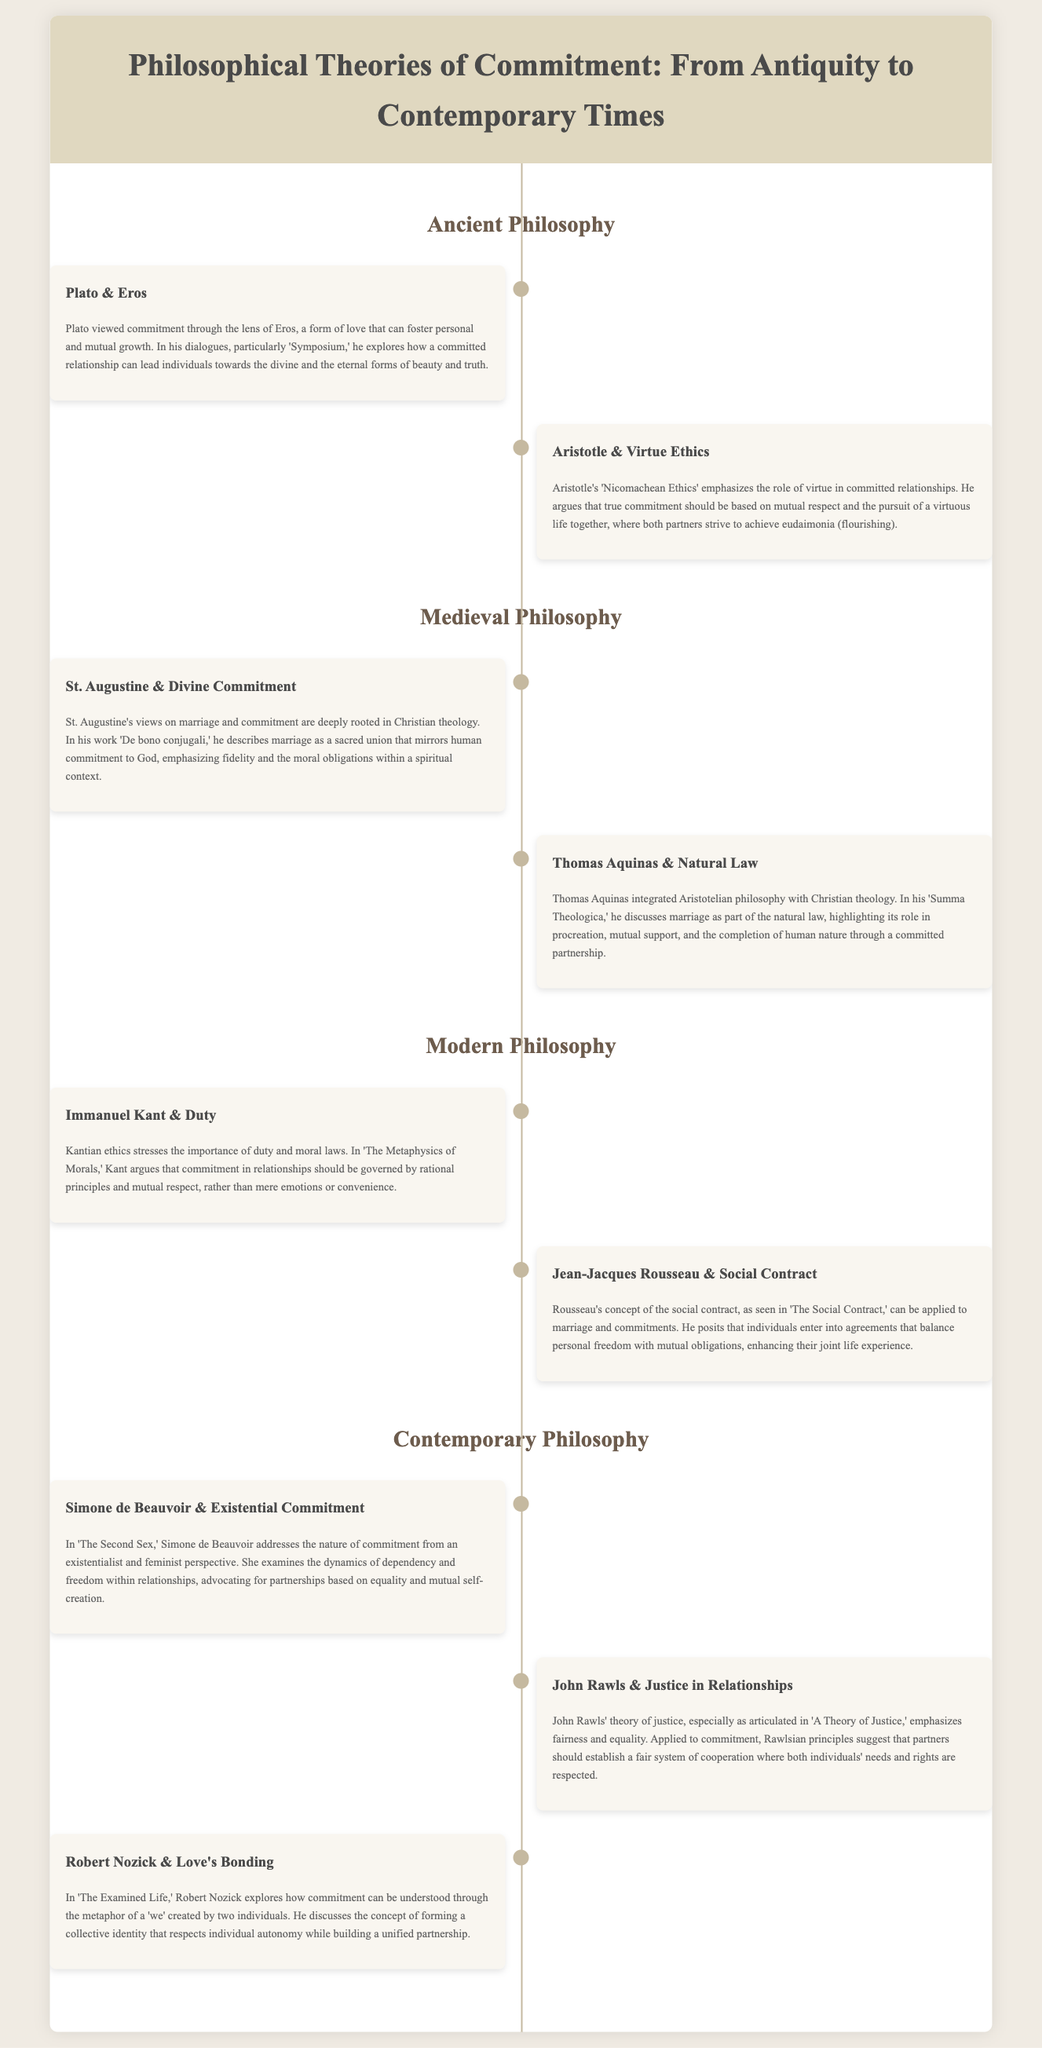What is the title of the infographic? The title presents the main theme of the document, which is about philosophical theories related to commitment.
Answer: Philosophical Theories of Commitment: From Antiquity to Contemporary Times Who wrote 'The Second Sex'? This question targets the specific philosopher associated with a well-known work that discusses existential commitment in relationships.
Answer: Simone de Beauvoir Which philosopher discusses duty in relationships? This question focuses on identifying the philosopher who emphasizes the importance of duty in relationships according to Kantian ethics.
Answer: Immanuel Kant What concept does Rousseau apply to marriage? This question seeks to uncover what philosophical concept Rousseau relates to marriage, highlighting the nature of agreements.
Answer: Social Contract In which work does Aristotle emphasize virtue in relationships? This question explores the title of Aristotle's influential text that discusses virtue ethics in the context of commitment.
Answer: Nicomachean Ethics What philosophical era is St. Augustine associated with? This question seeks to identify the historical period that St. Augustine's views on marriage align with.
Answer: Medieval Philosophy How many philosophers are mentioned in the contemporary era? This question addresses the count of philosophers discussed in the contemporary section of the infographic.
Answer: Three 